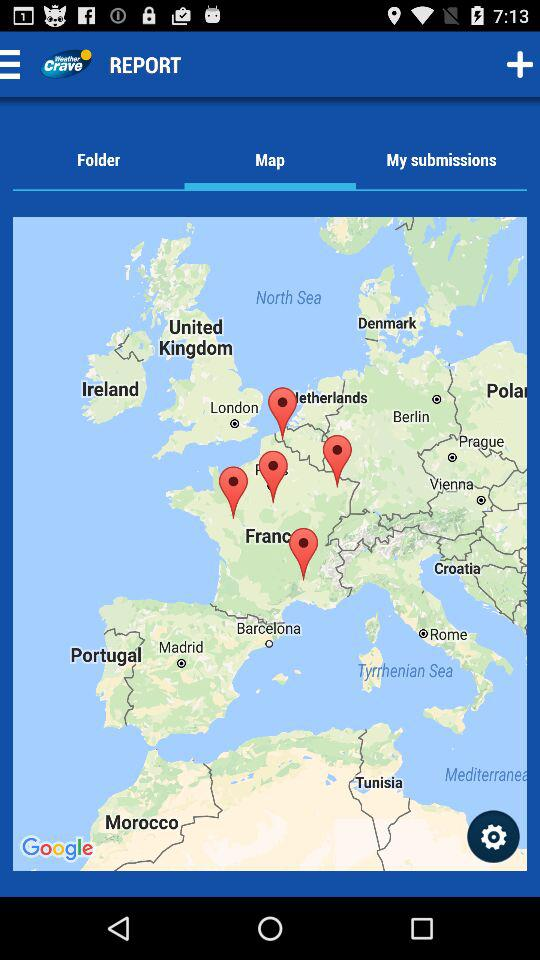When was the map first copyrighted?
When the provided information is insufficient, respond with <no answer>. <no answer> 